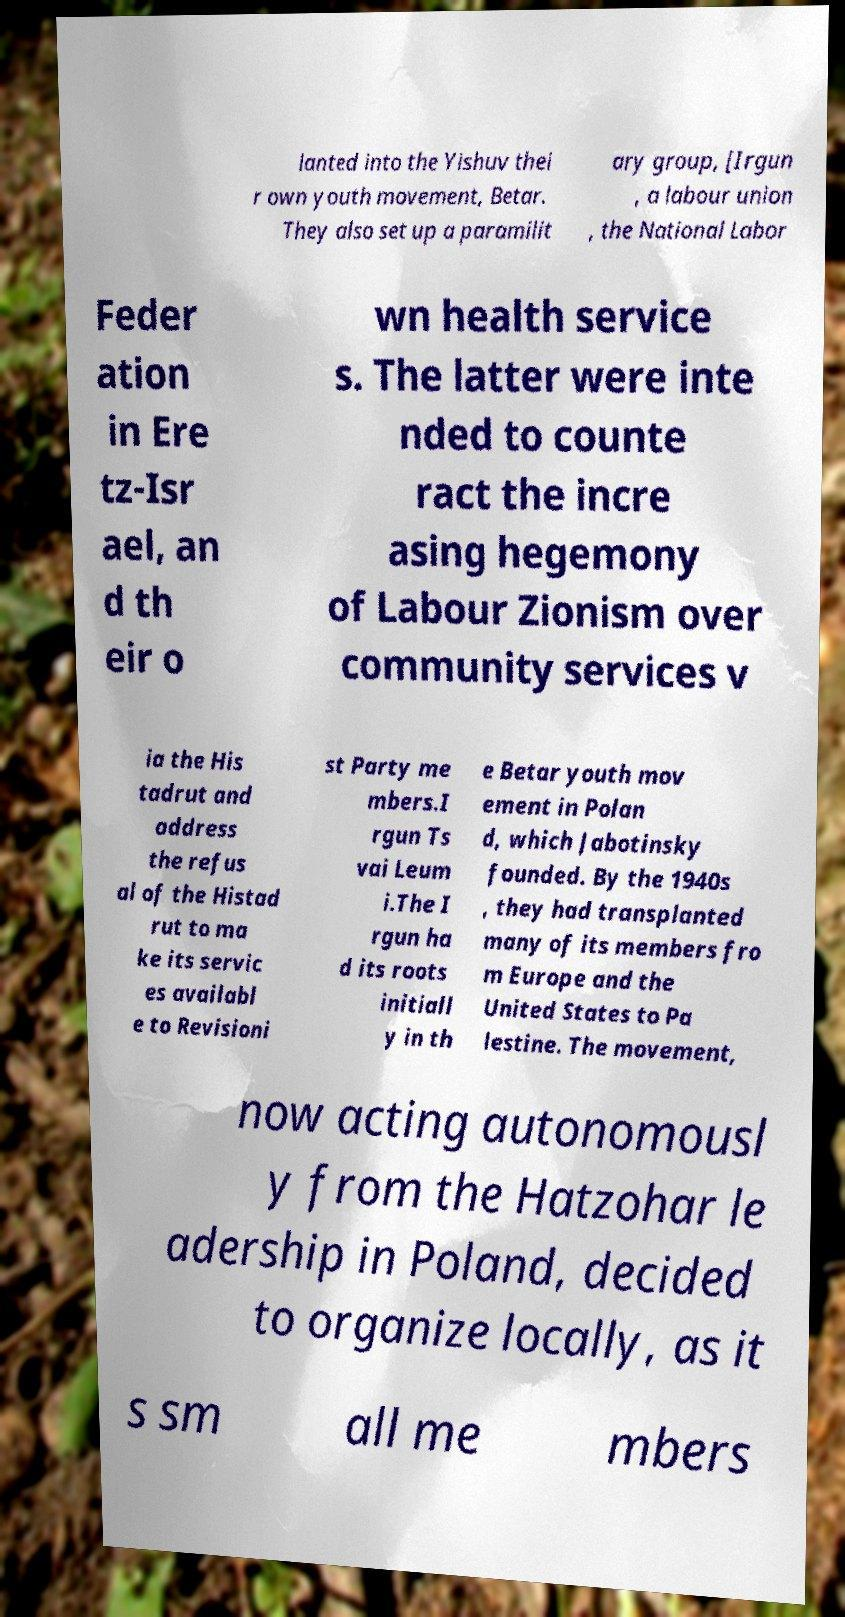Could you extract and type out the text from this image? lanted into the Yishuv thei r own youth movement, Betar. They also set up a paramilit ary group, [Irgun , a labour union , the National Labor Feder ation in Ere tz-Isr ael, an d th eir o wn health service s. The latter were inte nded to counte ract the incre asing hegemony of Labour Zionism over community services v ia the His tadrut and address the refus al of the Histad rut to ma ke its servic es availabl e to Revisioni st Party me mbers.I rgun Ts vai Leum i.The I rgun ha d its roots initiall y in th e Betar youth mov ement in Polan d, which Jabotinsky founded. By the 1940s , they had transplanted many of its members fro m Europe and the United States to Pa lestine. The movement, now acting autonomousl y from the Hatzohar le adership in Poland, decided to organize locally, as it s sm all me mbers 